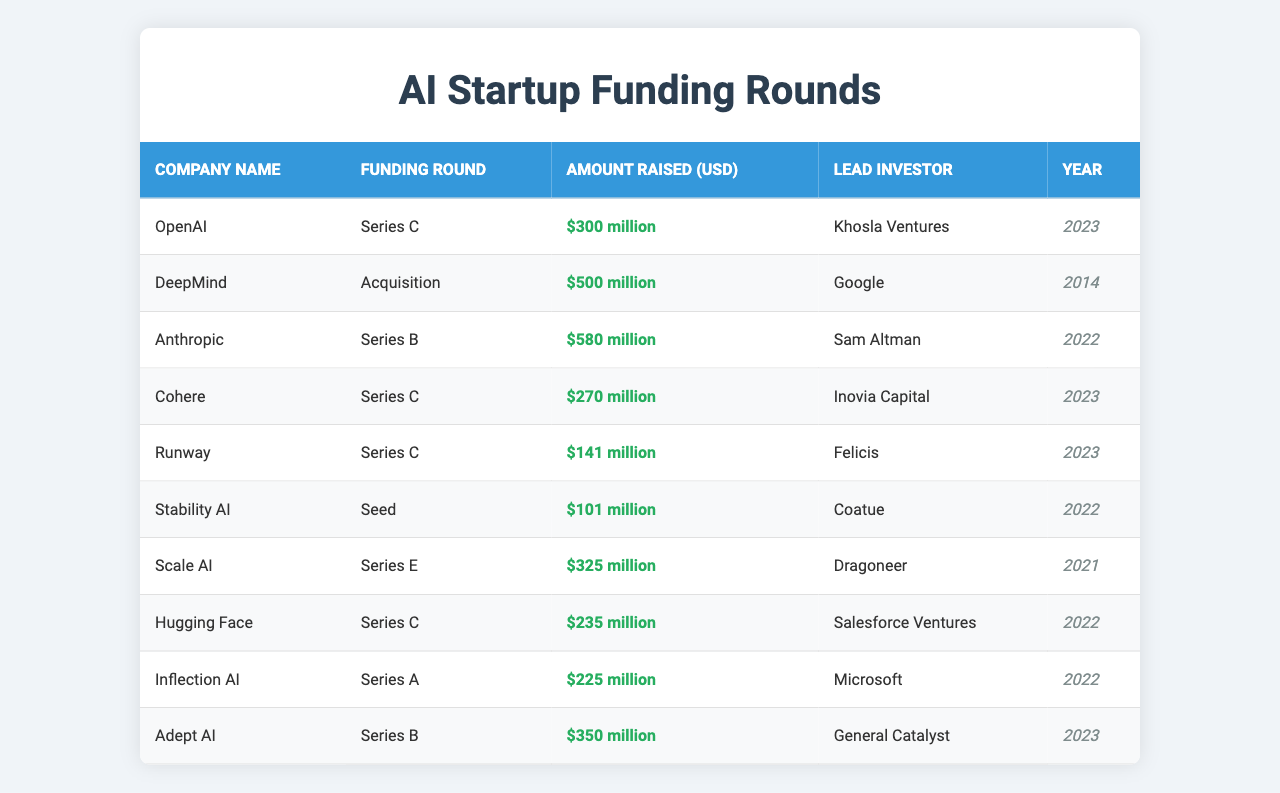What is the total funding amount raised in the Series C round? The table lists the companies that had Series C rounds: OpenAI ($300 million), Cohere ($270 million), and Runway ($141 million). Adding these amounts together gives a total of $300 million + $270 million + $141 million = $711 million.
Answer: $711 million Which company raised the highest amount in a single funding round? The table shows that Anthropic raised $580 million in Series B, which is the highest compared to others.
Answer: Anthropic Did any company raise more than $500 million? Yes, DeepMind raised $500 million in an acquisition round, which is exactly $500 million.
Answer: Yes How many companies had a funding round in the year 2023? The table lists the companies that had rounds in 2023: OpenAI, Cohere, Runway, and Adept AI. There are four companies in total.
Answer: 4 What is the average amount raised across all funding rounds listed? First, we sum all the amounts: $300 million + $500 million + $580 million + $270 million + $141 million + $101 million + $325 million + $235 million + $225 million + $350 million = $3.315 billion. There are 10 funding rounds, so the average is $3.315 billion / 10 = $331.5 million.
Answer: $331.5 million Which lead investor funded the most companies in this table? By examining the table, Khosla Ventures, Google, Sam Altman, Inovia Capital, Felicis, Coatue, Dragoneer, Salesforce Ventures, Microsoft, and General Catalyst each represent only a single investment. Thus, no lead investor is funding multiple companies listed in the table.
Answer: None What is the difference in funding amounts between the highest and lowest amounts raised? The highest amount raised is $580 million (Anthropic) and the lowest is $101 million (Stability AI). The difference is $580 million - $101 million = $479 million.
Answer: $479 million Which funding round was led by Microsoft and what was the amount raised? The table indicates that the Series A round led by Microsoft raised $225 million.
Answer: $225 million How many companies raised funds in the Seed round? The table shows that only Stability AI raised funds in the Seed round, so there is one company.
Answer: 1 What year did the most funding rounds take place? By reviewing the years listed, there are three companies that raised funds in 2023, two in 2022, and one in each of 2021 and 2014. Hence, 2023 had the most funding rounds.
Answer: 2023 